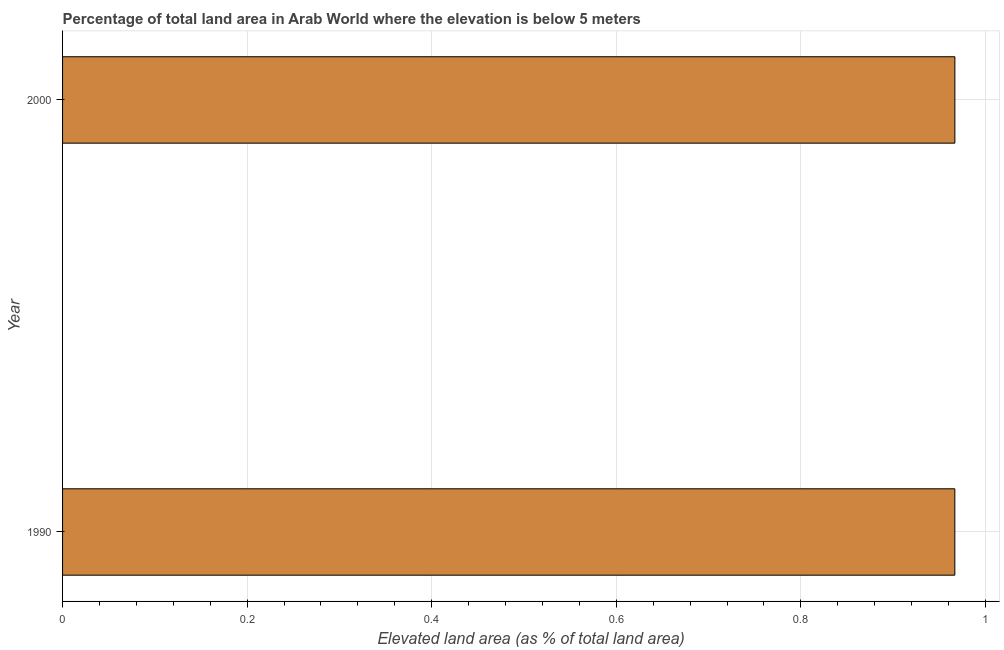Does the graph contain any zero values?
Your answer should be very brief. No. Does the graph contain grids?
Your answer should be compact. Yes. What is the title of the graph?
Offer a terse response. Percentage of total land area in Arab World where the elevation is below 5 meters. What is the label or title of the X-axis?
Offer a very short reply. Elevated land area (as % of total land area). What is the total elevated land area in 1990?
Provide a succinct answer. 0.97. Across all years, what is the maximum total elevated land area?
Provide a succinct answer. 0.97. Across all years, what is the minimum total elevated land area?
Provide a succinct answer. 0.97. What is the sum of the total elevated land area?
Keep it short and to the point. 1.93. What is the difference between the total elevated land area in 1990 and 2000?
Provide a short and direct response. -0. What is the average total elevated land area per year?
Offer a terse response. 0.97. What is the median total elevated land area?
Provide a succinct answer. 0.97. Do a majority of the years between 1990 and 2000 (inclusive) have total elevated land area greater than 0.12 %?
Provide a succinct answer. Yes. What is the ratio of the total elevated land area in 1990 to that in 2000?
Ensure brevity in your answer.  1. Is the total elevated land area in 1990 less than that in 2000?
Give a very brief answer. Yes. Are all the bars in the graph horizontal?
Offer a terse response. Yes. How many years are there in the graph?
Ensure brevity in your answer.  2. What is the difference between two consecutive major ticks on the X-axis?
Your answer should be compact. 0.2. Are the values on the major ticks of X-axis written in scientific E-notation?
Provide a succinct answer. No. What is the Elevated land area (as % of total land area) in 1990?
Offer a terse response. 0.97. What is the Elevated land area (as % of total land area) in 2000?
Ensure brevity in your answer.  0.97. What is the difference between the Elevated land area (as % of total land area) in 1990 and 2000?
Give a very brief answer. -6e-5. 